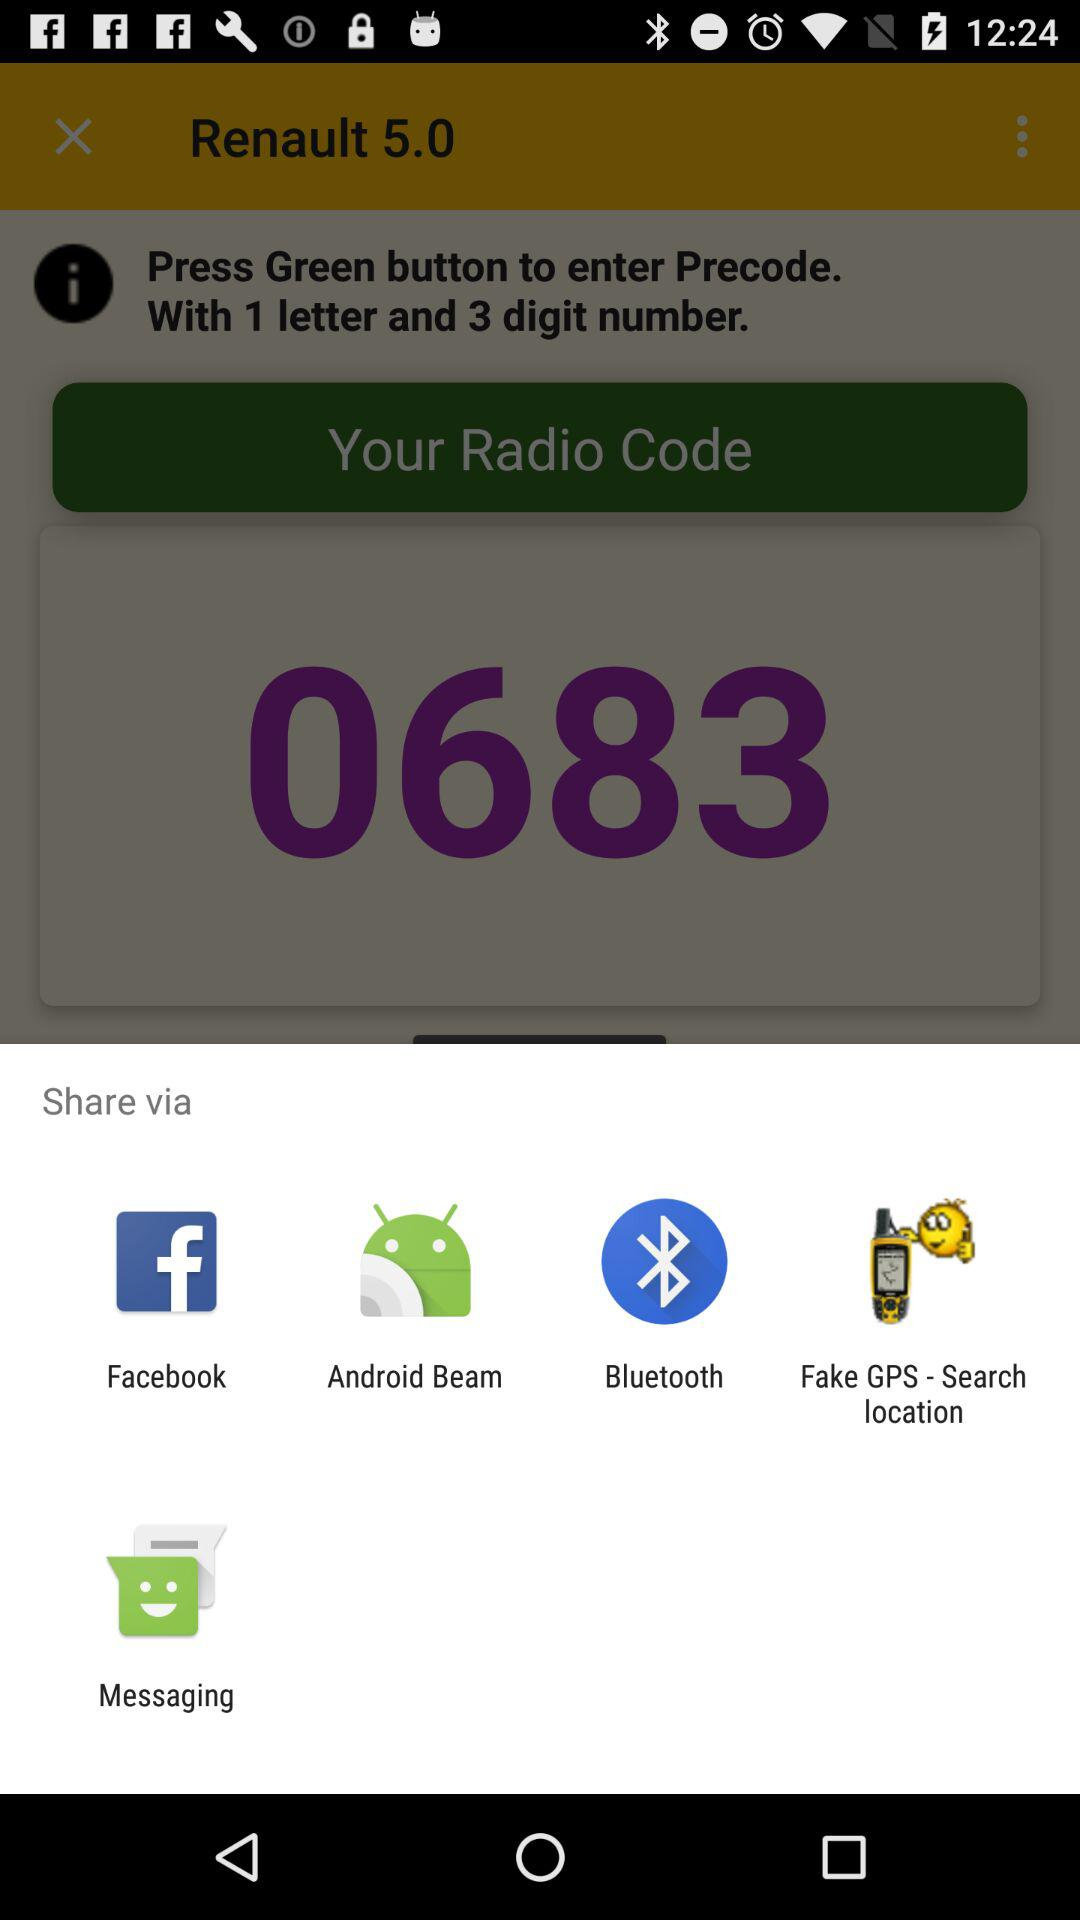What is the radio code? The radio code is 0683. 